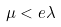<formula> <loc_0><loc_0><loc_500><loc_500>\mu < e \lambda</formula> 